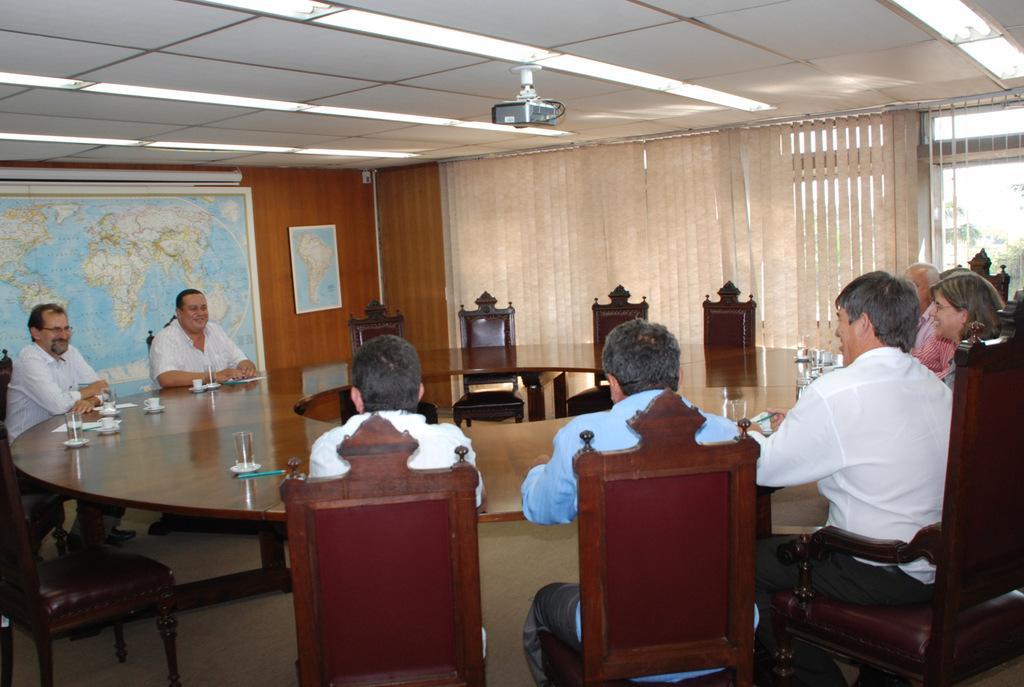Can you describe this image briefly? There are some people sitting in the chairs, around a table on which cups, glasses were placed. All of them were men. There is a woman in the right side. In the background there is a curtain and a world map attached to the walls. 